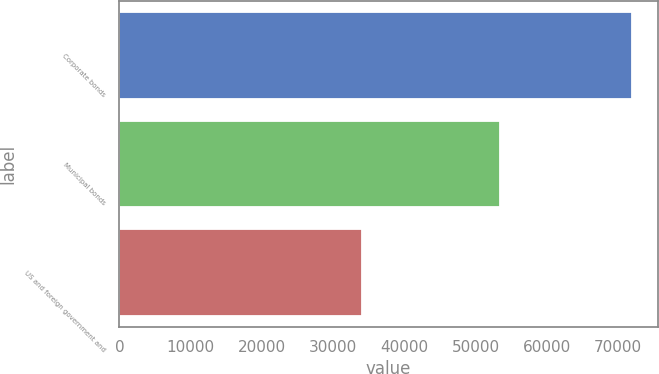<chart> <loc_0><loc_0><loc_500><loc_500><bar_chart><fcel>Corporate bonds<fcel>Municipal bonds<fcel>US and foreign government and<nl><fcel>71966<fcel>53491<fcel>34102<nl></chart> 